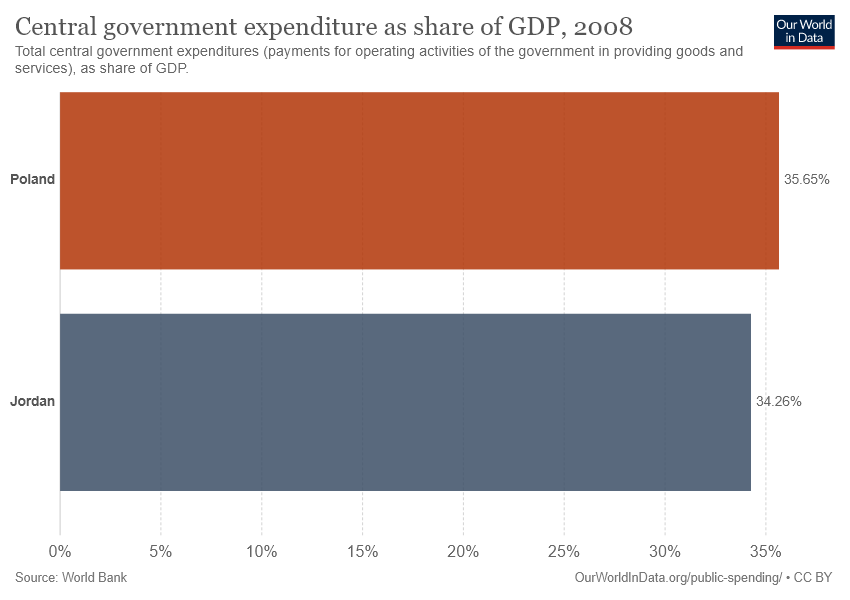Specify some key components in this picture. The difference between Poland and Jordan is approximately 0.0139... 